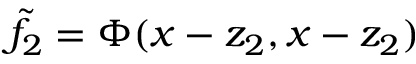<formula> <loc_0><loc_0><loc_500><loc_500>\tilde { f } _ { 2 } = \Phi ( x - z _ { 2 } , x - z _ { 2 } )</formula> 